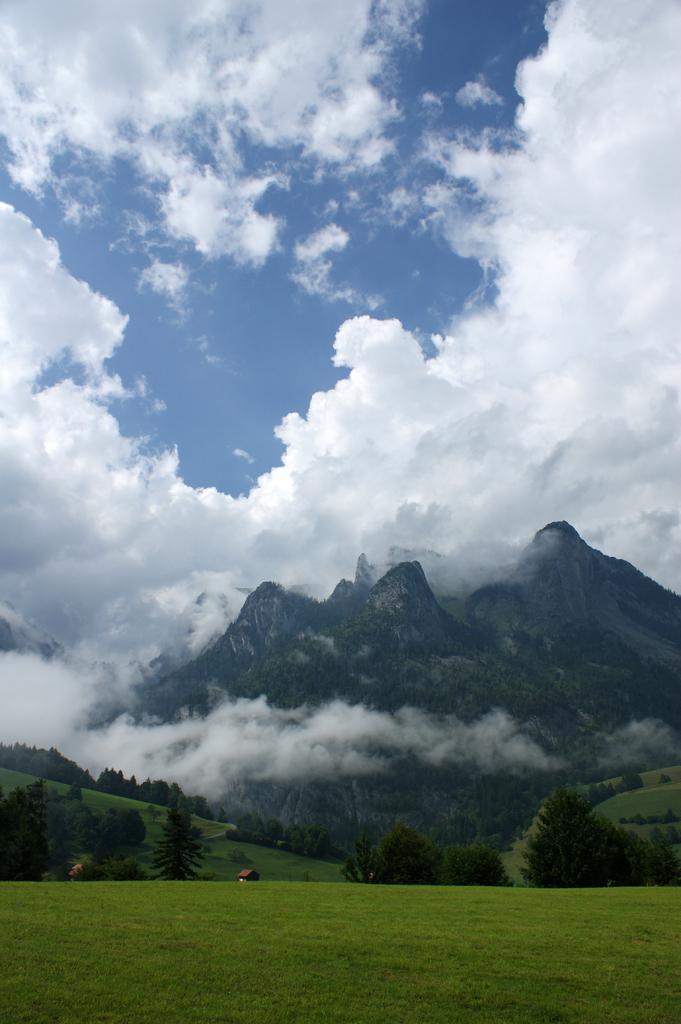Could you give a brief overview of what you see in this image? At the bottom we can see the farmland and grass. In the background there is a hut near to the trees. On the right we can see the mountains. At the top we can see sky and clouds. 